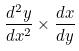Convert formula to latex. <formula><loc_0><loc_0><loc_500><loc_500>\frac { d ^ { 2 } y } { d x ^ { 2 } } \times \frac { d x } { d y }</formula> 